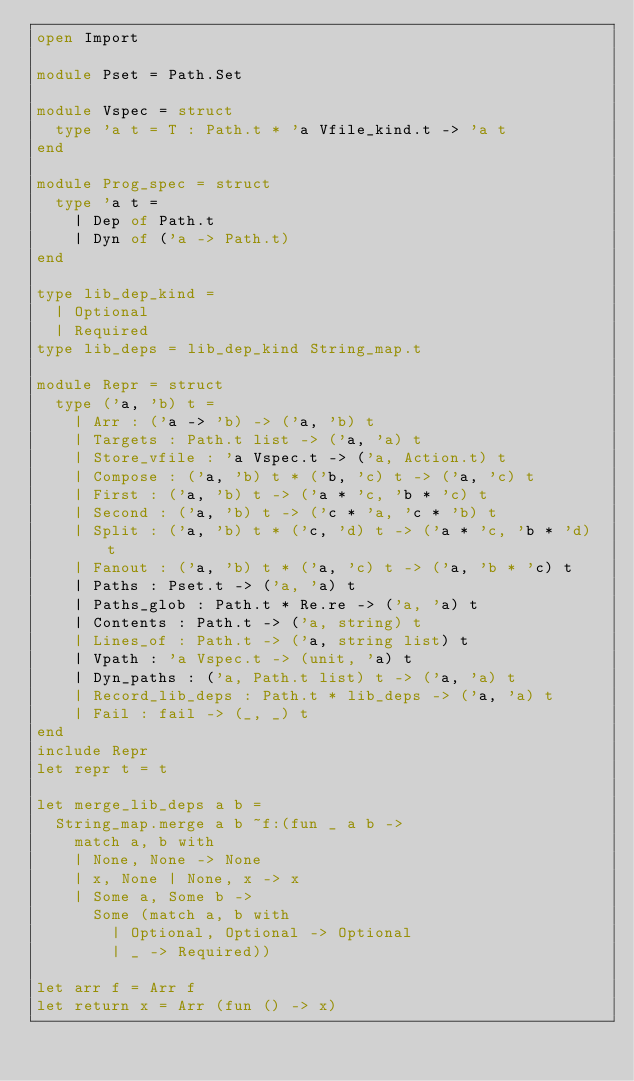Convert code to text. <code><loc_0><loc_0><loc_500><loc_500><_OCaml_>open Import

module Pset = Path.Set

module Vspec = struct
  type 'a t = T : Path.t * 'a Vfile_kind.t -> 'a t
end

module Prog_spec = struct
  type 'a t =
    | Dep of Path.t
    | Dyn of ('a -> Path.t)
end

type lib_dep_kind =
  | Optional
  | Required
type lib_deps = lib_dep_kind String_map.t

module Repr = struct
  type ('a, 'b) t =
    | Arr : ('a -> 'b) -> ('a, 'b) t
    | Targets : Path.t list -> ('a, 'a) t
    | Store_vfile : 'a Vspec.t -> ('a, Action.t) t
    | Compose : ('a, 'b) t * ('b, 'c) t -> ('a, 'c) t
    | First : ('a, 'b) t -> ('a * 'c, 'b * 'c) t
    | Second : ('a, 'b) t -> ('c * 'a, 'c * 'b) t
    | Split : ('a, 'b) t * ('c, 'd) t -> ('a * 'c, 'b * 'd) t
    | Fanout : ('a, 'b) t * ('a, 'c) t -> ('a, 'b * 'c) t
    | Paths : Pset.t -> ('a, 'a) t
    | Paths_glob : Path.t * Re.re -> ('a, 'a) t
    | Contents : Path.t -> ('a, string) t
    | Lines_of : Path.t -> ('a, string list) t
    | Vpath : 'a Vspec.t -> (unit, 'a) t
    | Dyn_paths : ('a, Path.t list) t -> ('a, 'a) t
    | Record_lib_deps : Path.t * lib_deps -> ('a, 'a) t
    | Fail : fail -> (_, _) t
end
include Repr
let repr t = t

let merge_lib_deps a b =
  String_map.merge a b ~f:(fun _ a b ->
    match a, b with
    | None, None -> None
    | x, None | None, x -> x
    | Some a, Some b ->
      Some (match a, b with
        | Optional, Optional -> Optional
        | _ -> Required))

let arr f = Arr f
let return x = Arr (fun () -> x)
</code> 